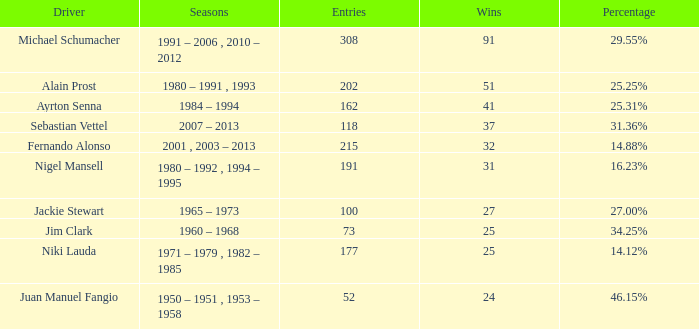Which season did jackie stewart enter with entries less than 215? 1965 – 1973. 